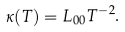<formula> <loc_0><loc_0><loc_500><loc_500>\kappa ( T ) = L _ { 0 0 } T ^ { - 2 } .</formula> 